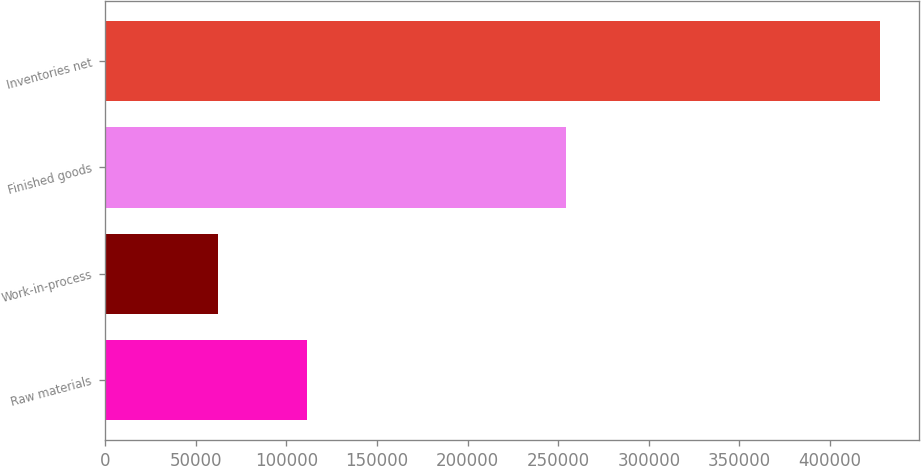Convert chart to OTSL. <chart><loc_0><loc_0><loc_500><loc_500><bar_chart><fcel>Raw materials<fcel>Work-in-process<fcel>Finished goods<fcel>Inventories net<nl><fcel>111105<fcel>62334<fcel>254339<fcel>427778<nl></chart> 